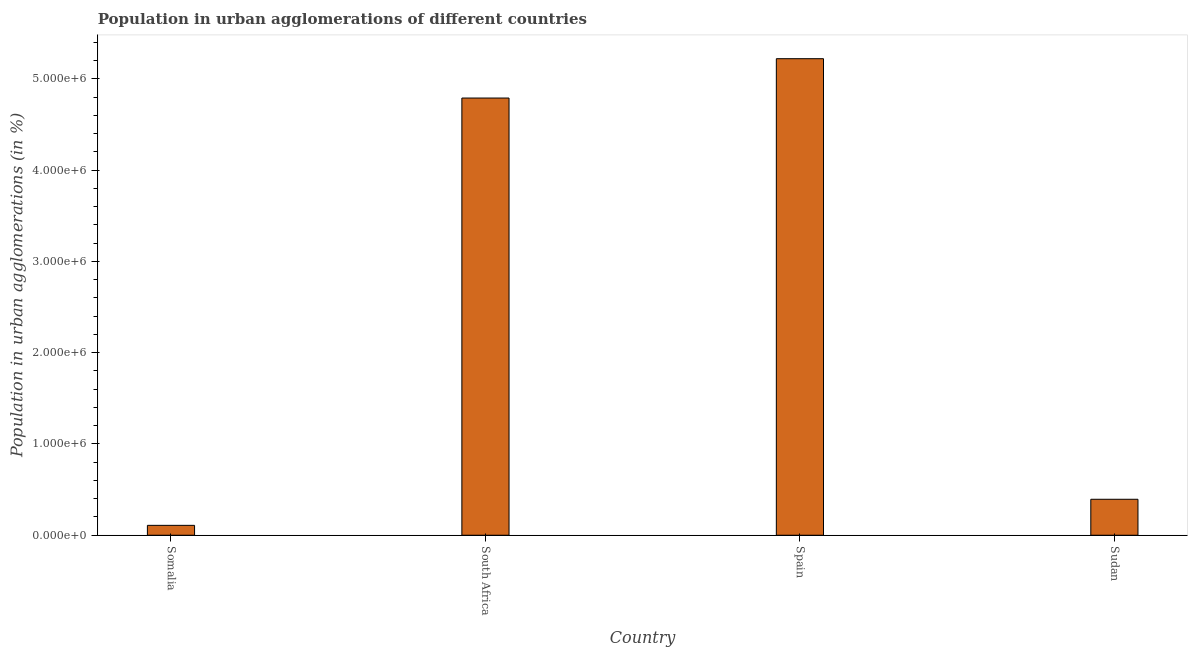Does the graph contain grids?
Provide a short and direct response. No. What is the title of the graph?
Give a very brief answer. Population in urban agglomerations of different countries. What is the label or title of the Y-axis?
Ensure brevity in your answer.  Population in urban agglomerations (in %). What is the population in urban agglomerations in Spain?
Keep it short and to the point. 5.22e+06. Across all countries, what is the maximum population in urban agglomerations?
Offer a terse response. 5.22e+06. Across all countries, what is the minimum population in urban agglomerations?
Your response must be concise. 1.08e+05. In which country was the population in urban agglomerations maximum?
Ensure brevity in your answer.  Spain. In which country was the population in urban agglomerations minimum?
Offer a very short reply. Somalia. What is the sum of the population in urban agglomerations?
Your answer should be compact. 1.05e+07. What is the difference between the population in urban agglomerations in Somalia and South Africa?
Your response must be concise. -4.68e+06. What is the average population in urban agglomerations per country?
Keep it short and to the point. 2.63e+06. What is the median population in urban agglomerations?
Give a very brief answer. 2.59e+06. In how many countries, is the population in urban agglomerations greater than 200000 %?
Offer a very short reply. 3. What is the ratio of the population in urban agglomerations in Somalia to that in Sudan?
Your answer should be very brief. 0.28. Is the difference between the population in urban agglomerations in Somalia and South Africa greater than the difference between any two countries?
Give a very brief answer. No. What is the difference between the highest and the second highest population in urban agglomerations?
Provide a short and direct response. 4.31e+05. Is the sum of the population in urban agglomerations in South Africa and Sudan greater than the maximum population in urban agglomerations across all countries?
Your answer should be very brief. No. What is the difference between the highest and the lowest population in urban agglomerations?
Give a very brief answer. 5.11e+06. In how many countries, is the population in urban agglomerations greater than the average population in urban agglomerations taken over all countries?
Provide a succinct answer. 2. Are all the bars in the graph horizontal?
Your response must be concise. No. Are the values on the major ticks of Y-axis written in scientific E-notation?
Your response must be concise. Yes. What is the Population in urban agglomerations (in %) of Somalia?
Your answer should be compact. 1.08e+05. What is the Population in urban agglomerations (in %) of South Africa?
Your response must be concise. 4.79e+06. What is the Population in urban agglomerations (in %) of Spain?
Keep it short and to the point. 5.22e+06. What is the Population in urban agglomerations (in %) of Sudan?
Your response must be concise. 3.94e+05. What is the difference between the Population in urban agglomerations (in %) in Somalia and South Africa?
Give a very brief answer. -4.68e+06. What is the difference between the Population in urban agglomerations (in %) in Somalia and Spain?
Make the answer very short. -5.11e+06. What is the difference between the Population in urban agglomerations (in %) in Somalia and Sudan?
Ensure brevity in your answer.  -2.86e+05. What is the difference between the Population in urban agglomerations (in %) in South Africa and Spain?
Your response must be concise. -4.31e+05. What is the difference between the Population in urban agglomerations (in %) in South Africa and Sudan?
Offer a terse response. 4.39e+06. What is the difference between the Population in urban agglomerations (in %) in Spain and Sudan?
Give a very brief answer. 4.83e+06. What is the ratio of the Population in urban agglomerations (in %) in Somalia to that in South Africa?
Your response must be concise. 0.02. What is the ratio of the Population in urban agglomerations (in %) in Somalia to that in Spain?
Provide a short and direct response. 0.02. What is the ratio of the Population in urban agglomerations (in %) in Somalia to that in Sudan?
Your response must be concise. 0.28. What is the ratio of the Population in urban agglomerations (in %) in South Africa to that in Spain?
Ensure brevity in your answer.  0.92. What is the ratio of the Population in urban agglomerations (in %) in South Africa to that in Sudan?
Provide a succinct answer. 12.16. What is the ratio of the Population in urban agglomerations (in %) in Spain to that in Sudan?
Make the answer very short. 13.25. 